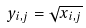<formula> <loc_0><loc_0><loc_500><loc_500>y _ { i , j } = \sqrt { x _ { i , j } }</formula> 